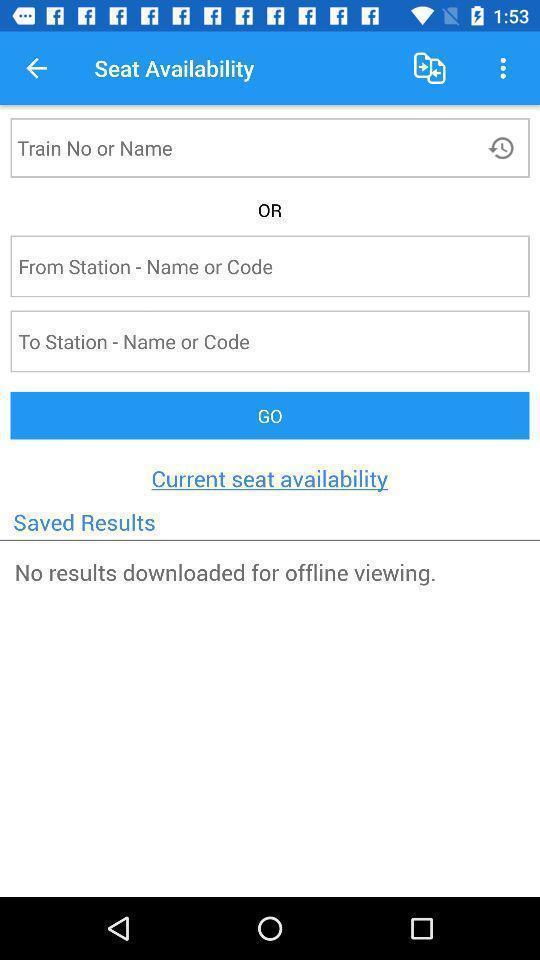Give me a summary of this screen capture. Screen shows seat information in train app. 